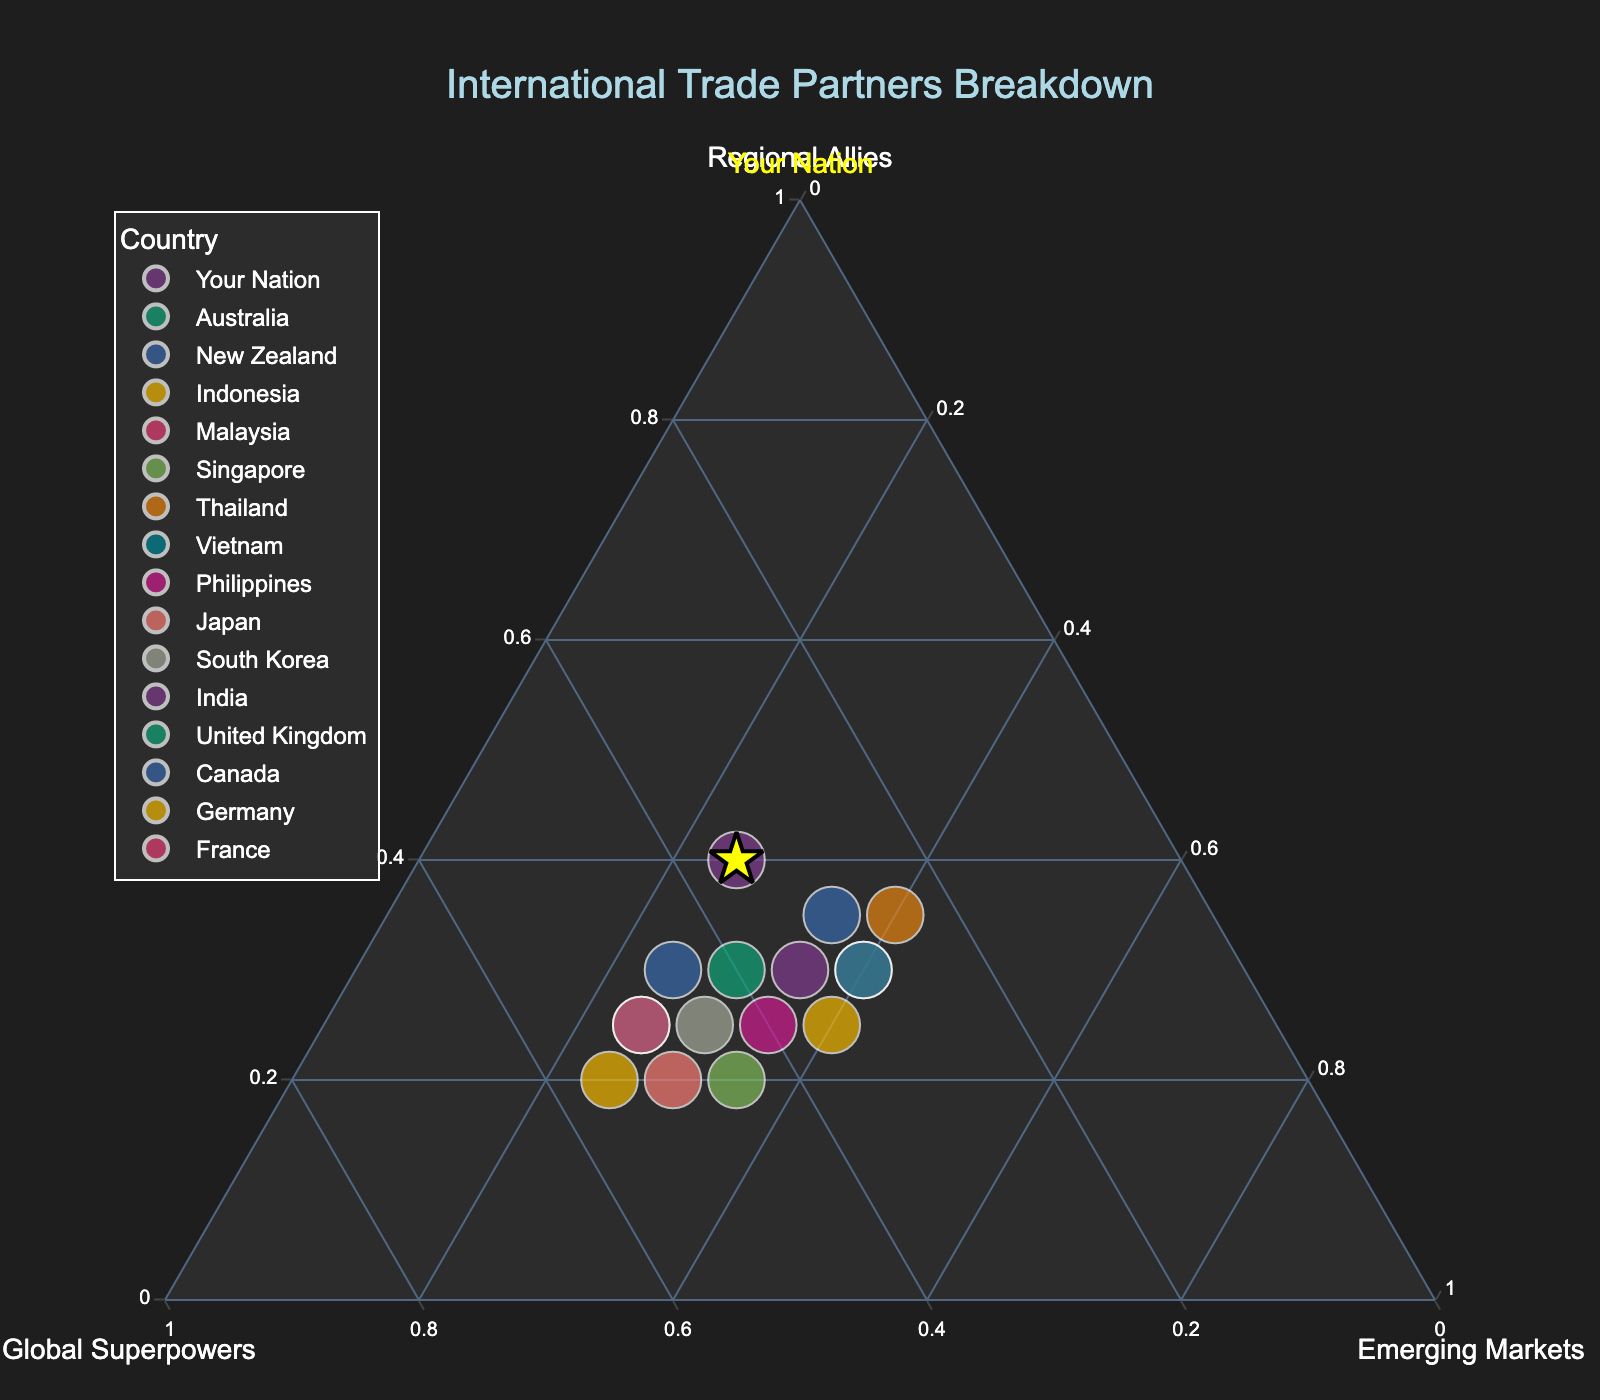what is the title of the plot? The title of the plot is displayed at the top of the figure. It helps in understanding what the plot represents. The title of this plot is "International Trade Partners Breakdown."
Answer: International Trade Partners Breakdown How many countries have more than 40% of their trade with global superpowers? To find the number of countries with more than 40% trade with global superpowers, visually inspect the figure for data points located past the 40% mark on the global superpowers axis. The countries meeting this criterion are Singapore, Japan, South Korea, United Kingdom, Canada, Germany, and France.
Answer: 7 What is the trade distribution for your nation? Identify "Your Nation" in the plot. It was highlighted with a yellow star, labeled, and likely centered in the plot. The trade distribution for "Your Nation" is 40% Regional Allies, 35% Global Superpowers, and 25% Emerging Markets.
Answer: 40% Regional Allies, 35% Global Superpowers, 25% Emerging Markets Compare the trade distribution of Australia and New Zealand. Which country has a higher percentage of trade with emerging markets? Find the positions of Australia and New Zealand and compare their coordinates. Australia has 30% trade with emerging markets, whereas New Zealand has 35%. Thus, New Zealand has a higher percentage of trade with emerging markets.
Answer: New Zealand Which countries have an equal percentage of trade with global superpowers and emerging markets? Look for countries positioned diagonally where the values for global superpowers and emerging markets are equal, e.g., New Zealand has 35% trade with both global superpowers and emerging markets.
Answer: New Zealand What is the average percentage of trade with regional allies for all countries listed? Add up the percentage values for trade with regional allies for all countries and divide by the total number of countries. \((40 + 30 + 35 + 25 + 30 + 20 + 35 + 30 + 25 + 20 + 25 + 30 + 25 + 30 + 20 + 25)/15 = 28.33\)
Answer: 28.3% How does the trade distribution of Germany compare to that of the United Kingdom in terms of global superpowers? Compare the values on the global superpowers axis for Germany and the United Kingdom. Both Germany and the United Kingdom have 50% trade with global superpowers.
Answer: Equal What percentage of trade for Japan is with regional allies? Locate Japan in the plot and check its coordinates on the regional allies axis. For Japan, it is 20%.
Answer: 20% Rank the countries by their percentage of trade with emerging markets from highest to lowest. Who has the highest? Check the coordinates on the emerging markets axis and rank them. The country with the highest percentage is Indonesia with 40%.
Answer: Indonesia 